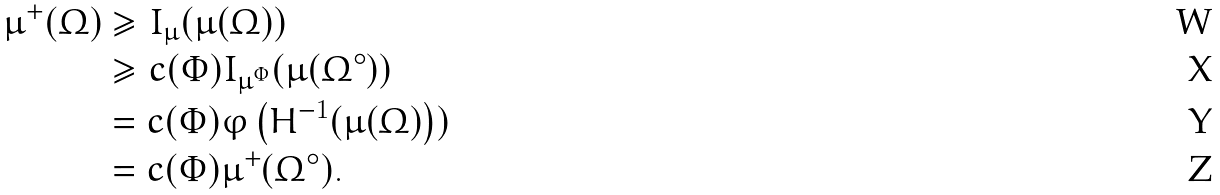<formula> <loc_0><loc_0><loc_500><loc_500>\mu ^ { + } ( \Omega ) & \geq I _ { \mu } ( \mu ( \Omega ) ) \\ & \geq c ( \Phi ) I _ { \mu ^ { \Phi } } ( \mu ( \Omega ^ { \circ } ) ) \\ & = c ( \Phi ) \varphi \left ( H ^ { - 1 } ( \mu ( \Omega ) \right ) ) \\ & = c ( \Phi ) \mu ^ { + } ( \Omega ^ { \circ } ) .</formula> 